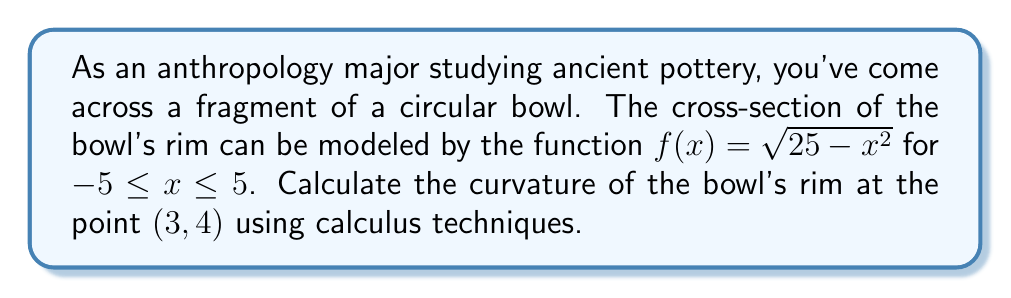Teach me how to tackle this problem. To find the curvature at a point, we'll use the formula:

$$\kappa = \frac{|f''(x)|}{(1 + [f'(x)]^2)^{3/2}}$$

Step 1: Find $f'(x)$
$$f'(x) = \frac{d}{dx}(\sqrt{25 - x^2}) = \frac{-2x}{2\sqrt{25 - x^2}} = \frac{-x}{\sqrt{25 - x^2}}$$

Step 2: Find $f''(x)$
$$f''(x) = \frac{d}{dx}(\frac{-x}{\sqrt{25 - x^2}}) = \frac{-(25 - x^2) + x^2}{(25 - x^2)^{3/2}} = \frac{-25}{(25 - x^2)^{3/2}}$$

Step 3: Evaluate $f'(3)$ and $f''(3)$
$$f'(3) = \frac{-3}{\sqrt{25 - 3^2}} = \frac{-3}{4} = -0.75$$
$$f''(3) = \frac{-25}{(25 - 3^2)^{3/2}} = \frac{-25}{64} = -0.390625$$

Step 4: Calculate the curvature using the formula
$$\kappa = \frac{|-0.390625|}{(1 + [-0.75]^2)^{3/2}} = \frac{0.390625}{(1.5625)^{3/2}} = \frac{0.390625}{1.953125} = 0.2$$

Therefore, the curvature of the bowl's rim at the point (3, 4) is 0.2.
Answer: $\kappa = 0.2$ 